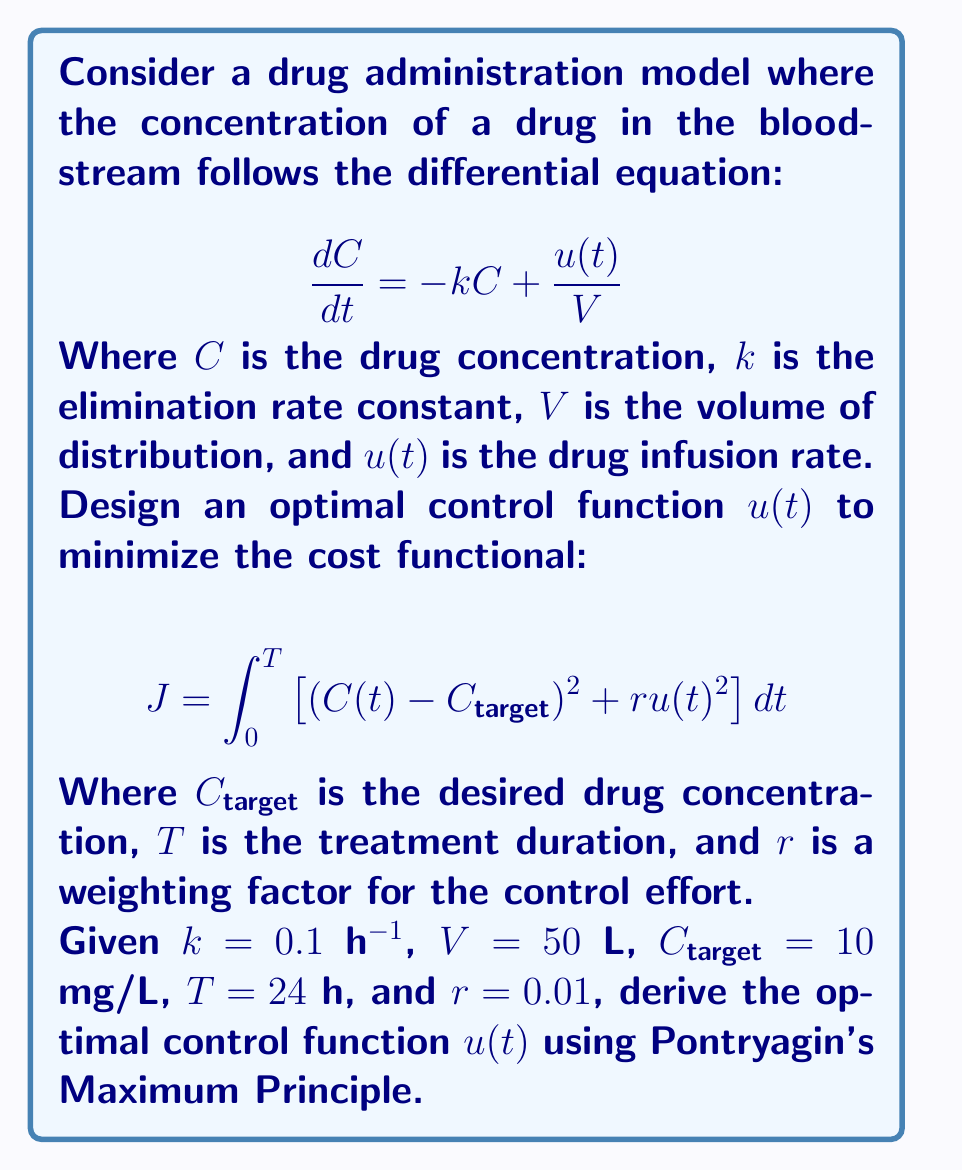Help me with this question. To solve this optimal control problem, we'll use Pontryagin's Maximum Principle:

1) Define the Hamiltonian:
   $$H = (C - C_{target})^2 + ru^2 + \lambda(-kC + \frac{u}{V})$$

2) Derive the costate equation:
   $$\frac{d\lambda}{dt} = -\frac{\partial H}{\partial C} = -2(C - C_{target}) + k\lambda$$

3) Optimal control condition:
   $$\frac{\partial H}{\partial u} = 2ru + \frac{\lambda}{V} = 0$$
   $$u^* = -\frac{\lambda}{2rV}$$

4) State and costate equations:
   $$\frac{dC}{dt} = -kC - \frac{\lambda}{2rV^2}$$
   $$\frac{d\lambda}{dt} = -2(C - C_{target}) + k\lambda$$

5) Boundary conditions:
   $C(0) = 0$ (initial condition)
   $\lambda(T) = 0$ (transversality condition)

6) Solve the system of differential equations:
   The solution has the form:
   $$C(t) = A_1e^{\alpha_1 t} + A_2e^{\alpha_2 t} + C_{target}$$
   $$\lambda(t) = B_1e^{\alpha_1 t} + B_2e^{\alpha_2 t}$$

   Where $\alpha_1$ and $\alpha_2$ are the eigenvalues of the system matrix:
   $$\alpha_{1,2} = \frac{1}{2}\left(k \pm \sqrt{k^2 + \frac{4}{rV^2}}\right)$$

7) Apply boundary conditions to find $A_1$, $A_2$, $B_1$, and $B_2$.

8) The optimal control function is:
   $$u^*(t) = -\frac{1}{2rV}(B_1e^{\alpha_1 t} + B_2e^{\alpha_2 t})$$

Substituting the given values:
$k = 0.1$ h⁻¹, $V = 50$ L, $C_{target} = 10$ mg/L, $T = 24$ h, and $r = 0.01$

We can numerically solve for the coefficients and obtain the final optimal control function.
Answer: $u^*(t) = -\frac{1}{rV}(B_1e^{\alpha_1 t} + B_2e^{\alpha_2 t})$, where $B_1$, $B_2$, $\alpha_1$, and $\alpha_2$ are constants determined by the system parameters and boundary conditions. 